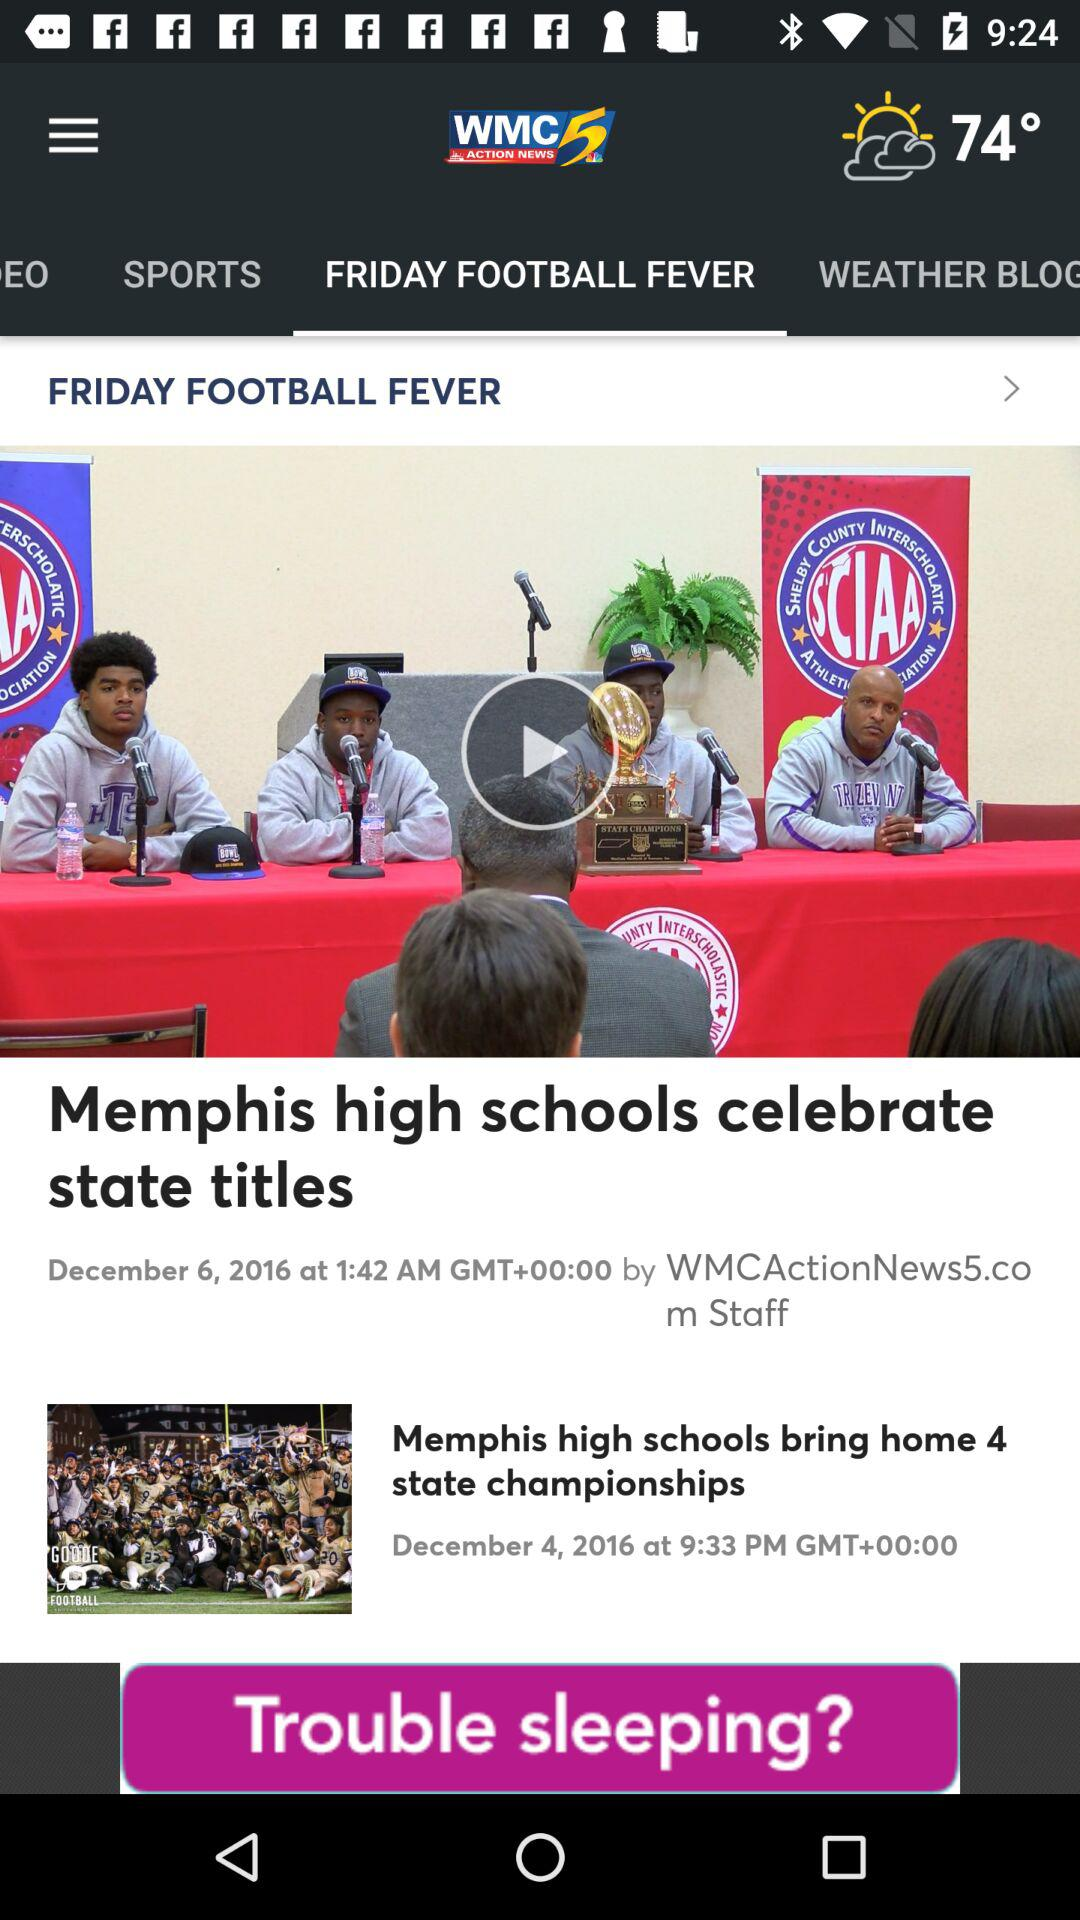What is the time when the news "Memphis high schools celebrate state titles" is uploaded? The time is 1:42 AM GMT+00:00. 